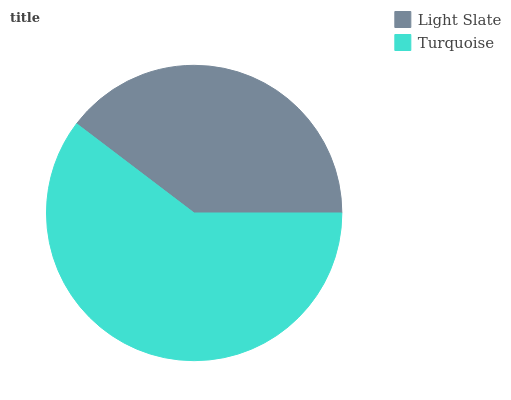Is Light Slate the minimum?
Answer yes or no. Yes. Is Turquoise the maximum?
Answer yes or no. Yes. Is Turquoise the minimum?
Answer yes or no. No. Is Turquoise greater than Light Slate?
Answer yes or no. Yes. Is Light Slate less than Turquoise?
Answer yes or no. Yes. Is Light Slate greater than Turquoise?
Answer yes or no. No. Is Turquoise less than Light Slate?
Answer yes or no. No. Is Turquoise the high median?
Answer yes or no. Yes. Is Light Slate the low median?
Answer yes or no. Yes. Is Light Slate the high median?
Answer yes or no. No. Is Turquoise the low median?
Answer yes or no. No. 